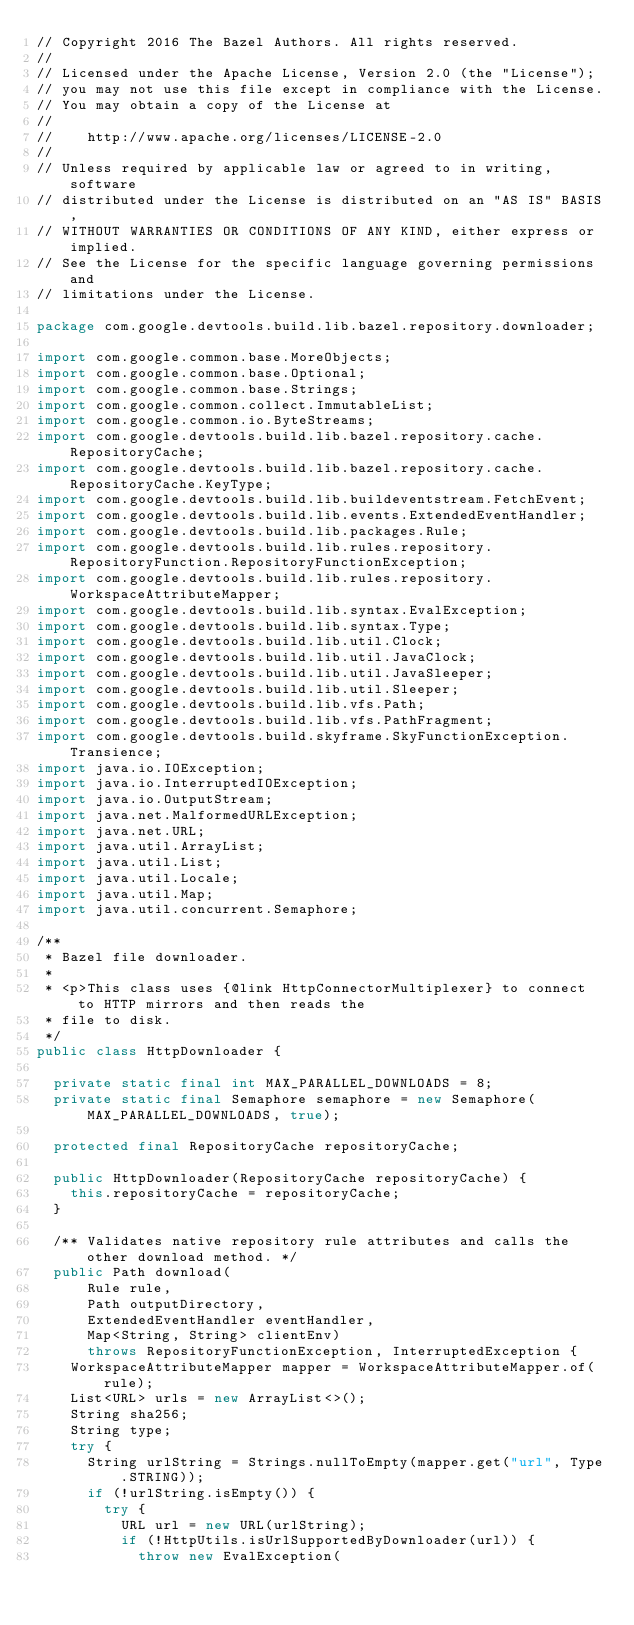Convert code to text. <code><loc_0><loc_0><loc_500><loc_500><_Java_>// Copyright 2016 The Bazel Authors. All rights reserved.
//
// Licensed under the Apache License, Version 2.0 (the "License");
// you may not use this file except in compliance with the License.
// You may obtain a copy of the License at
//
//    http://www.apache.org/licenses/LICENSE-2.0
//
// Unless required by applicable law or agreed to in writing, software
// distributed under the License is distributed on an "AS IS" BASIS,
// WITHOUT WARRANTIES OR CONDITIONS OF ANY KIND, either express or implied.
// See the License for the specific language governing permissions and
// limitations under the License.

package com.google.devtools.build.lib.bazel.repository.downloader;

import com.google.common.base.MoreObjects;
import com.google.common.base.Optional;
import com.google.common.base.Strings;
import com.google.common.collect.ImmutableList;
import com.google.common.io.ByteStreams;
import com.google.devtools.build.lib.bazel.repository.cache.RepositoryCache;
import com.google.devtools.build.lib.bazel.repository.cache.RepositoryCache.KeyType;
import com.google.devtools.build.lib.buildeventstream.FetchEvent;
import com.google.devtools.build.lib.events.ExtendedEventHandler;
import com.google.devtools.build.lib.packages.Rule;
import com.google.devtools.build.lib.rules.repository.RepositoryFunction.RepositoryFunctionException;
import com.google.devtools.build.lib.rules.repository.WorkspaceAttributeMapper;
import com.google.devtools.build.lib.syntax.EvalException;
import com.google.devtools.build.lib.syntax.Type;
import com.google.devtools.build.lib.util.Clock;
import com.google.devtools.build.lib.util.JavaClock;
import com.google.devtools.build.lib.util.JavaSleeper;
import com.google.devtools.build.lib.util.Sleeper;
import com.google.devtools.build.lib.vfs.Path;
import com.google.devtools.build.lib.vfs.PathFragment;
import com.google.devtools.build.skyframe.SkyFunctionException.Transience;
import java.io.IOException;
import java.io.InterruptedIOException;
import java.io.OutputStream;
import java.net.MalformedURLException;
import java.net.URL;
import java.util.ArrayList;
import java.util.List;
import java.util.Locale;
import java.util.Map;
import java.util.concurrent.Semaphore;

/**
 * Bazel file downloader.
 *
 * <p>This class uses {@link HttpConnectorMultiplexer} to connect to HTTP mirrors and then reads the
 * file to disk.
 */
public class HttpDownloader {

  private static final int MAX_PARALLEL_DOWNLOADS = 8;
  private static final Semaphore semaphore = new Semaphore(MAX_PARALLEL_DOWNLOADS, true);

  protected final RepositoryCache repositoryCache;

  public HttpDownloader(RepositoryCache repositoryCache) {
    this.repositoryCache = repositoryCache;
  }

  /** Validates native repository rule attributes and calls the other download method. */
  public Path download(
      Rule rule,
      Path outputDirectory,
      ExtendedEventHandler eventHandler,
      Map<String, String> clientEnv)
      throws RepositoryFunctionException, InterruptedException {
    WorkspaceAttributeMapper mapper = WorkspaceAttributeMapper.of(rule);
    List<URL> urls = new ArrayList<>();
    String sha256;
    String type;
    try {
      String urlString = Strings.nullToEmpty(mapper.get("url", Type.STRING));
      if (!urlString.isEmpty()) {
        try {
          URL url = new URL(urlString);
          if (!HttpUtils.isUrlSupportedByDownloader(url)) {
            throw new EvalException(</code> 